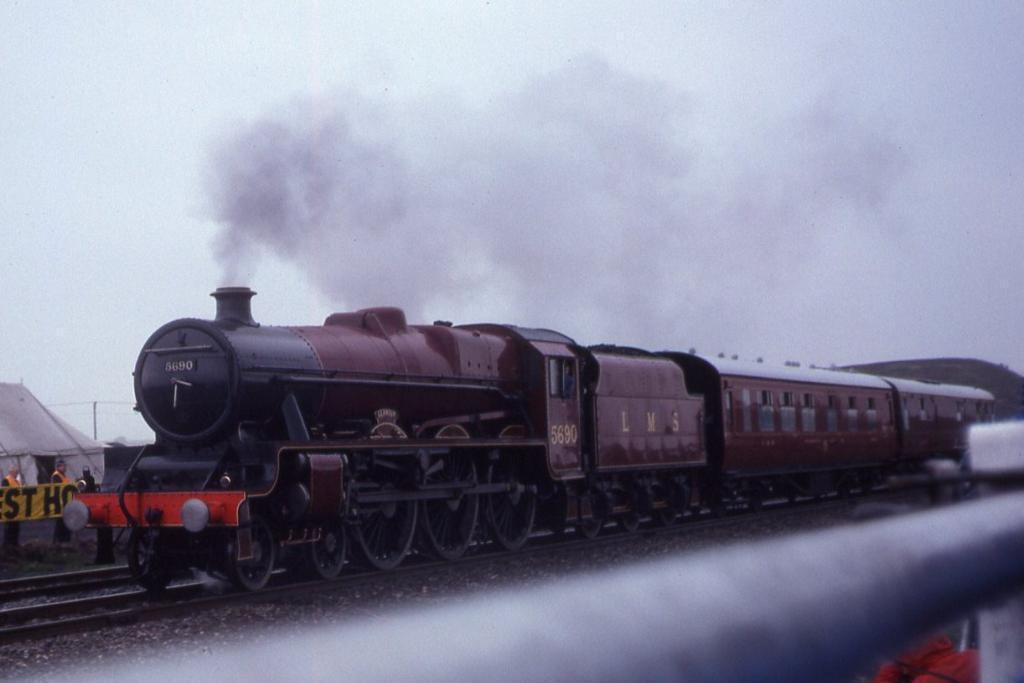Please provide a concise description of this image. There is a train moving on the railway track, it is emitting smoke from the top and there is a tent behind the train and two people were standing outside the tent. 